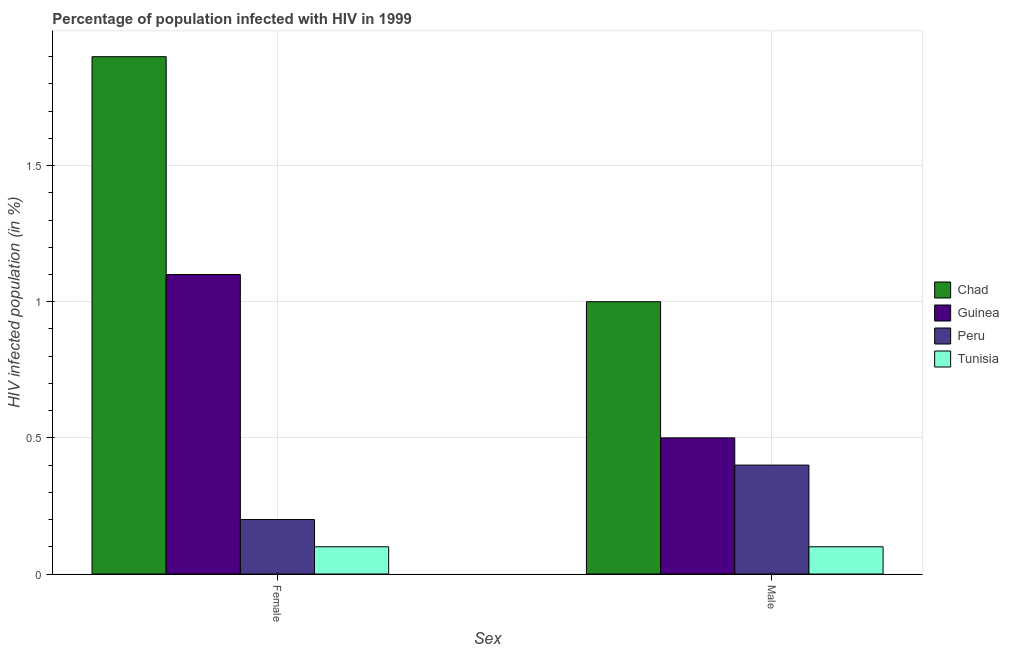How many different coloured bars are there?
Make the answer very short. 4. How many groups of bars are there?
Provide a succinct answer. 2. Are the number of bars per tick equal to the number of legend labels?
Offer a terse response. Yes. Are the number of bars on each tick of the X-axis equal?
Offer a very short reply. Yes. How many bars are there on the 1st tick from the left?
Give a very brief answer. 4. How many bars are there on the 2nd tick from the right?
Give a very brief answer. 4. What is the label of the 1st group of bars from the left?
Keep it short and to the point. Female. What is the percentage of males who are infected with hiv in Tunisia?
Your answer should be compact. 0.1. Across all countries, what is the maximum percentage of males who are infected with hiv?
Your response must be concise. 1. In which country was the percentage of males who are infected with hiv maximum?
Ensure brevity in your answer.  Chad. In which country was the percentage of females who are infected with hiv minimum?
Provide a succinct answer. Tunisia. What is the total percentage of females who are infected with hiv in the graph?
Offer a terse response. 3.3. What is the difference between the percentage of females who are infected with hiv in Tunisia and that in Chad?
Provide a succinct answer. -1.8. What is the difference between the percentage of males who are infected with hiv in Guinea and the percentage of females who are infected with hiv in Chad?
Provide a succinct answer. -1.4. What is the difference between the percentage of males who are infected with hiv and percentage of females who are infected with hiv in Chad?
Offer a terse response. -0.9. In how many countries, is the percentage of females who are infected with hiv greater than 1.2 %?
Your answer should be very brief. 1. Is the percentage of females who are infected with hiv in Tunisia less than that in Guinea?
Give a very brief answer. Yes. In how many countries, is the percentage of males who are infected with hiv greater than the average percentage of males who are infected with hiv taken over all countries?
Ensure brevity in your answer.  1. What does the 4th bar from the left in Male represents?
Offer a terse response. Tunisia. What does the 2nd bar from the right in Female represents?
Your answer should be very brief. Peru. Does the graph contain grids?
Provide a succinct answer. Yes. How are the legend labels stacked?
Make the answer very short. Vertical. What is the title of the graph?
Offer a terse response. Percentage of population infected with HIV in 1999. What is the label or title of the X-axis?
Provide a short and direct response. Sex. What is the label or title of the Y-axis?
Offer a terse response. HIV infected population (in %). What is the HIV infected population (in %) of Peru in Female?
Your response must be concise. 0.2. What is the HIV infected population (in %) of Tunisia in Female?
Ensure brevity in your answer.  0.1. What is the HIV infected population (in %) of Guinea in Male?
Give a very brief answer. 0.5. Across all Sex, what is the maximum HIV infected population (in %) of Chad?
Keep it short and to the point. 1.9. Across all Sex, what is the maximum HIV infected population (in %) in Guinea?
Offer a terse response. 1.1. Across all Sex, what is the maximum HIV infected population (in %) of Tunisia?
Offer a very short reply. 0.1. What is the total HIV infected population (in %) in Chad in the graph?
Your response must be concise. 2.9. What is the difference between the HIV infected population (in %) of Chad in Female and the HIV infected population (in %) of Guinea in Male?
Keep it short and to the point. 1.4. What is the difference between the HIV infected population (in %) of Chad in Female and the HIV infected population (in %) of Tunisia in Male?
Make the answer very short. 1.8. What is the difference between the HIV infected population (in %) in Guinea in Female and the HIV infected population (in %) in Tunisia in Male?
Your response must be concise. 1. What is the average HIV infected population (in %) of Chad per Sex?
Make the answer very short. 1.45. What is the average HIV infected population (in %) in Peru per Sex?
Your answer should be compact. 0.3. What is the difference between the HIV infected population (in %) in Chad and HIV infected population (in %) in Peru in Female?
Your answer should be compact. 1.7. What is the difference between the HIV infected population (in %) in Chad and HIV infected population (in %) in Tunisia in Female?
Your answer should be compact. 1.8. What is the difference between the HIV infected population (in %) in Guinea and HIV infected population (in %) in Peru in Female?
Keep it short and to the point. 0.9. What is the difference between the HIV infected population (in %) of Guinea and HIV infected population (in %) of Tunisia in Female?
Your response must be concise. 1. What is the difference between the HIV infected population (in %) in Peru and HIV infected population (in %) in Tunisia in Female?
Your answer should be very brief. 0.1. What is the difference between the HIV infected population (in %) of Chad and HIV infected population (in %) of Peru in Male?
Provide a short and direct response. 0.6. What is the difference between the HIV infected population (in %) of Chad and HIV infected population (in %) of Tunisia in Male?
Provide a succinct answer. 0.9. What is the difference between the HIV infected population (in %) in Peru and HIV infected population (in %) in Tunisia in Male?
Keep it short and to the point. 0.3. What is the ratio of the HIV infected population (in %) in Guinea in Female to that in Male?
Make the answer very short. 2.2. What is the difference between the highest and the second highest HIV infected population (in %) of Chad?
Provide a short and direct response. 0.9. What is the difference between the highest and the second highest HIV infected population (in %) in Guinea?
Provide a succinct answer. 0.6. What is the difference between the highest and the second highest HIV infected population (in %) in Peru?
Your response must be concise. 0.2. What is the difference between the highest and the second highest HIV infected population (in %) of Tunisia?
Your answer should be very brief. 0. What is the difference between the highest and the lowest HIV infected population (in %) of Chad?
Offer a very short reply. 0.9. What is the difference between the highest and the lowest HIV infected population (in %) in Peru?
Your answer should be compact. 0.2. What is the difference between the highest and the lowest HIV infected population (in %) of Tunisia?
Your answer should be very brief. 0. 